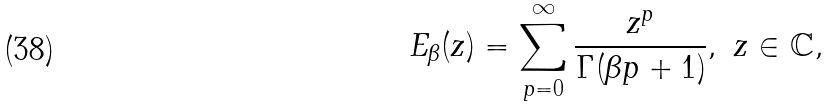Convert formula to latex. <formula><loc_0><loc_0><loc_500><loc_500>E _ { \beta } ( z ) = \sum _ { p = 0 } ^ { \infty } { \frac { z ^ { p } } { \Gamma ( \beta p + 1 ) } } , \ z \in \mathbb { C } ,</formula> 